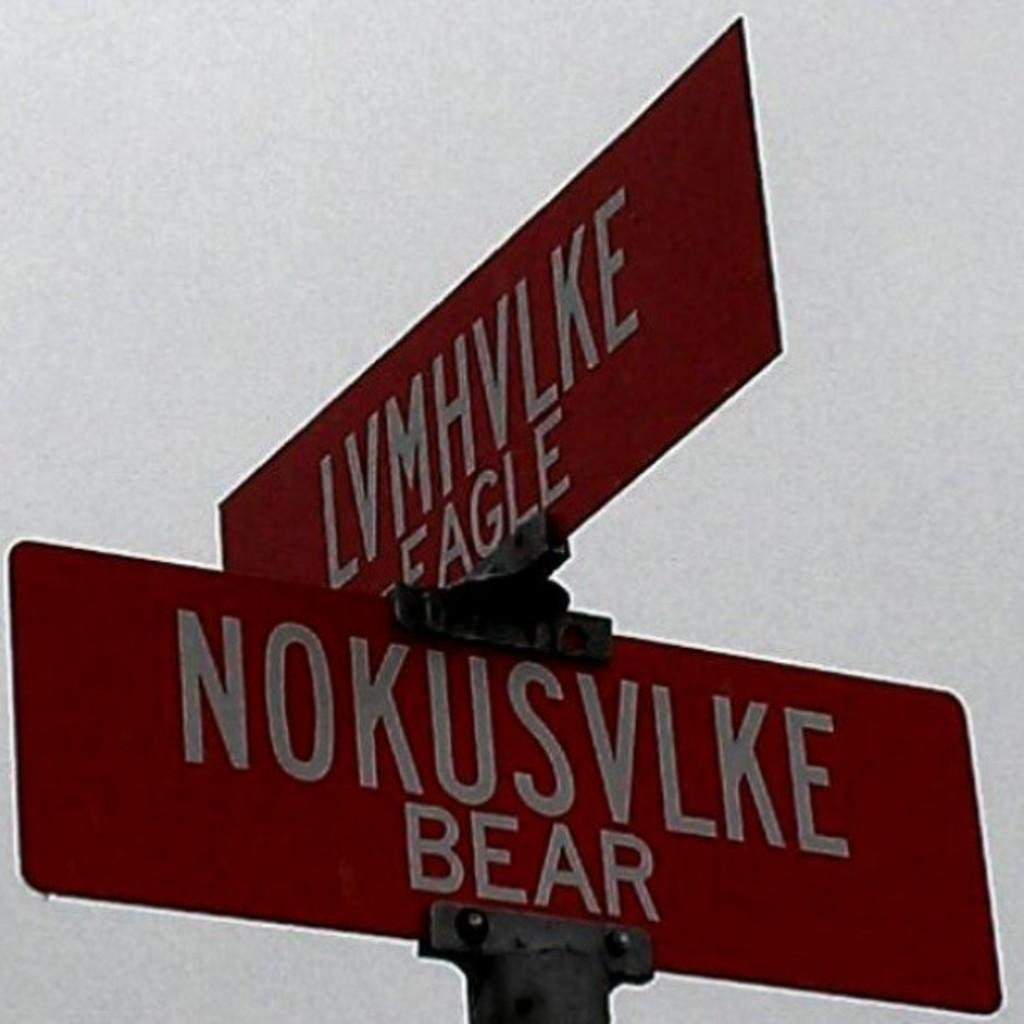What objects in the image have text on them? There are two boards with text in the image. What can be seen in the background of the image? The sky is visible in the image. What type of insurance is being advertised on the boards in the image? There is no indication of insurance being advertised on the boards in the image. Can you see a church in the background of the image? There is no church visible in the image; only the sky is present in the background. 